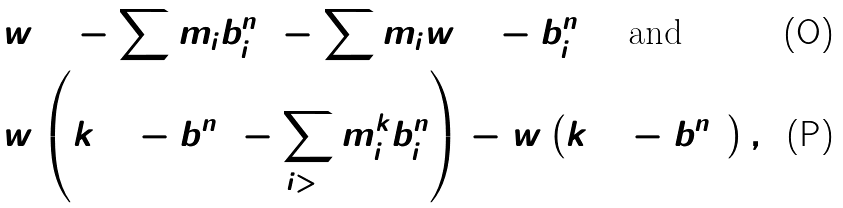Convert formula to latex. <formula><loc_0><loc_0><loc_500><loc_500>& w ( 1 - \sum m _ { i } b _ { i } ^ { n } ) - \sum m _ { i } w ( 1 - b _ { i } ^ { n } ) \quad \text {and} \\ & w \left ( k ( 1 - b _ { 1 } ^ { n } ) - \sum _ { i > 1 } m _ { i } ^ { k } b _ { i } ^ { n } \right ) - w \left ( k ( 1 - b _ { 1 } ^ { n } ) \right ) ,</formula> 